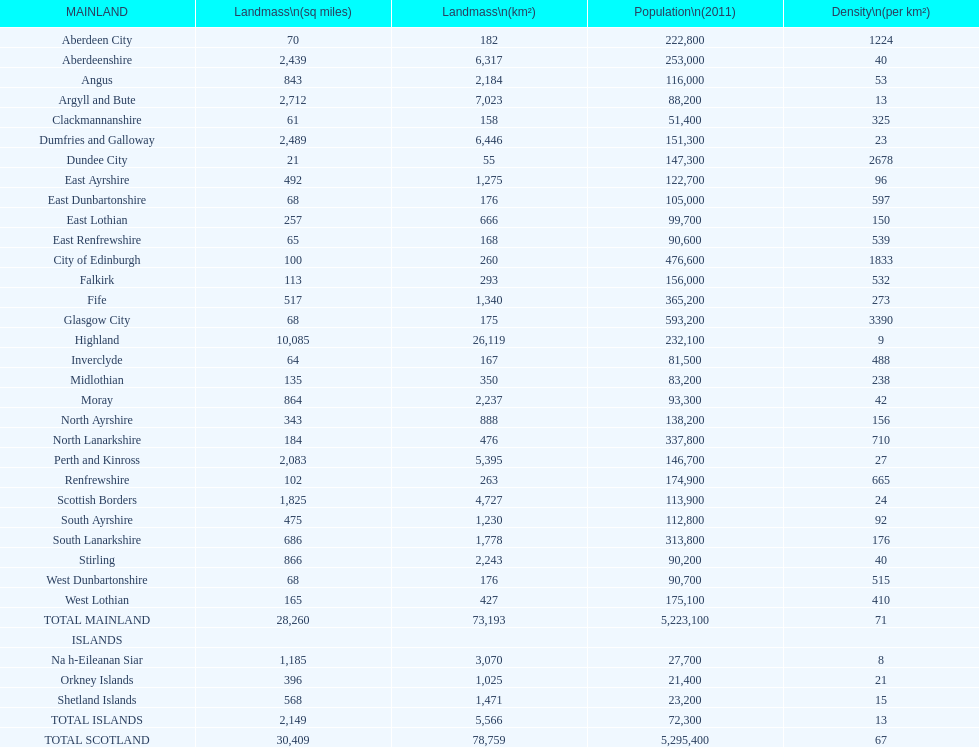Could you parse the entire table? {'header': ['MAINLAND', 'Landmass\\n(sq miles)', 'Landmass\\n(km²)', 'Population\\n(2011)', 'Density\\n(per km²)'], 'rows': [['Aberdeen City', '70', '182', '222,800', '1224'], ['Aberdeenshire', '2,439', '6,317', '253,000', '40'], ['Angus', '843', '2,184', '116,000', '53'], ['Argyll and Bute', '2,712', '7,023', '88,200', '13'], ['Clackmannanshire', '61', '158', '51,400', '325'], ['Dumfries and Galloway', '2,489', '6,446', '151,300', '23'], ['Dundee City', '21', '55', '147,300', '2678'], ['East Ayrshire', '492', '1,275', '122,700', '96'], ['East Dunbartonshire', '68', '176', '105,000', '597'], ['East Lothian', '257', '666', '99,700', '150'], ['East Renfrewshire', '65', '168', '90,600', '539'], ['City of Edinburgh', '100', '260', '476,600', '1833'], ['Falkirk', '113', '293', '156,000', '532'], ['Fife', '517', '1,340', '365,200', '273'], ['Glasgow City', '68', '175', '593,200', '3390'], ['Highland', '10,085', '26,119', '232,100', '9'], ['Inverclyde', '64', '167', '81,500', '488'], ['Midlothian', '135', '350', '83,200', '238'], ['Moray', '864', '2,237', '93,300', '42'], ['North Ayrshire', '343', '888', '138,200', '156'], ['North Lanarkshire', '184', '476', '337,800', '710'], ['Perth and Kinross', '2,083', '5,395', '146,700', '27'], ['Renfrewshire', '102', '263', '174,900', '665'], ['Scottish Borders', '1,825', '4,727', '113,900', '24'], ['South Ayrshire', '475', '1,230', '112,800', '92'], ['South Lanarkshire', '686', '1,778', '313,800', '176'], ['Stirling', '866', '2,243', '90,200', '40'], ['West Dunbartonshire', '68', '176', '90,700', '515'], ['West Lothian', '165', '427', '175,100', '410'], ['TOTAL MAINLAND', '28,260', '73,193', '5,223,100', '71'], ['ISLANDS', '', '', '', ''], ['Na h-Eileanan Siar', '1,185', '3,070', '27,700', '8'], ['Orkney Islands', '396', '1,025', '21,400', '21'], ['Shetland Islands', '568', '1,471', '23,200', '15'], ['TOTAL ISLANDS', '2,149', '5,566', '72,300', '13'], ['TOTAL SCOTLAND', '30,409', '78,759', '5,295,400', '67']]} What is the average population density in mainland cities? 71. 